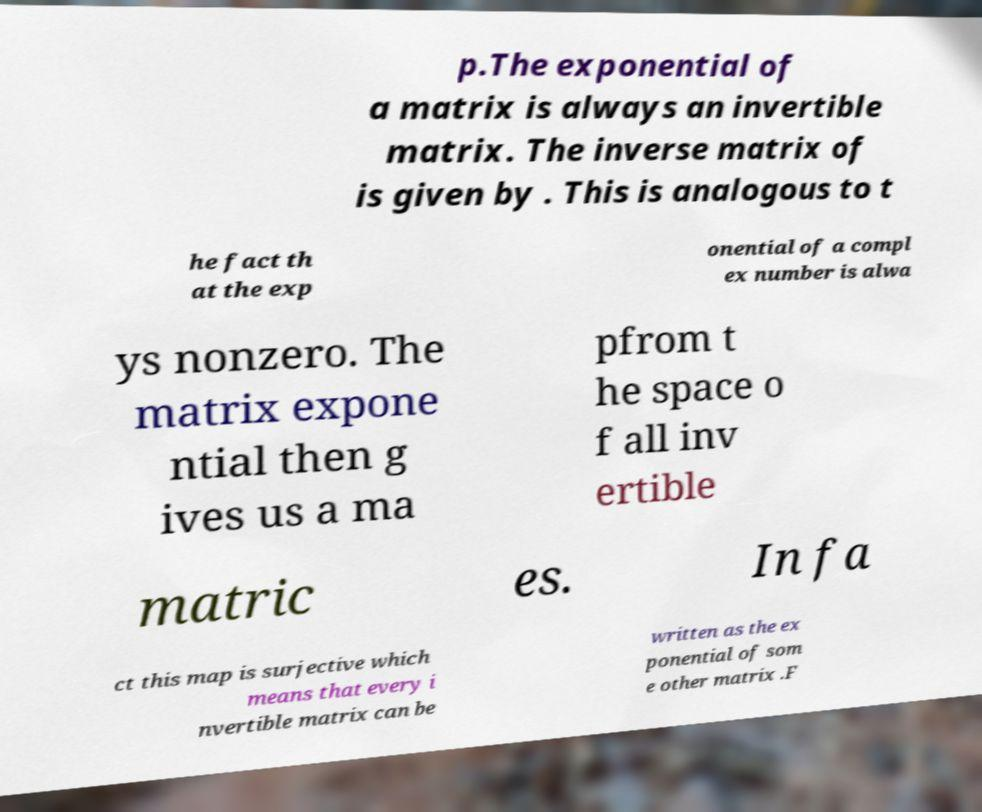There's text embedded in this image that I need extracted. Can you transcribe it verbatim? p.The exponential of a matrix is always an invertible matrix. The inverse matrix of is given by . This is analogous to t he fact th at the exp onential of a compl ex number is alwa ys nonzero. The matrix expone ntial then g ives us a ma pfrom t he space o f all inv ertible matric es. In fa ct this map is surjective which means that every i nvertible matrix can be written as the ex ponential of som e other matrix .F 